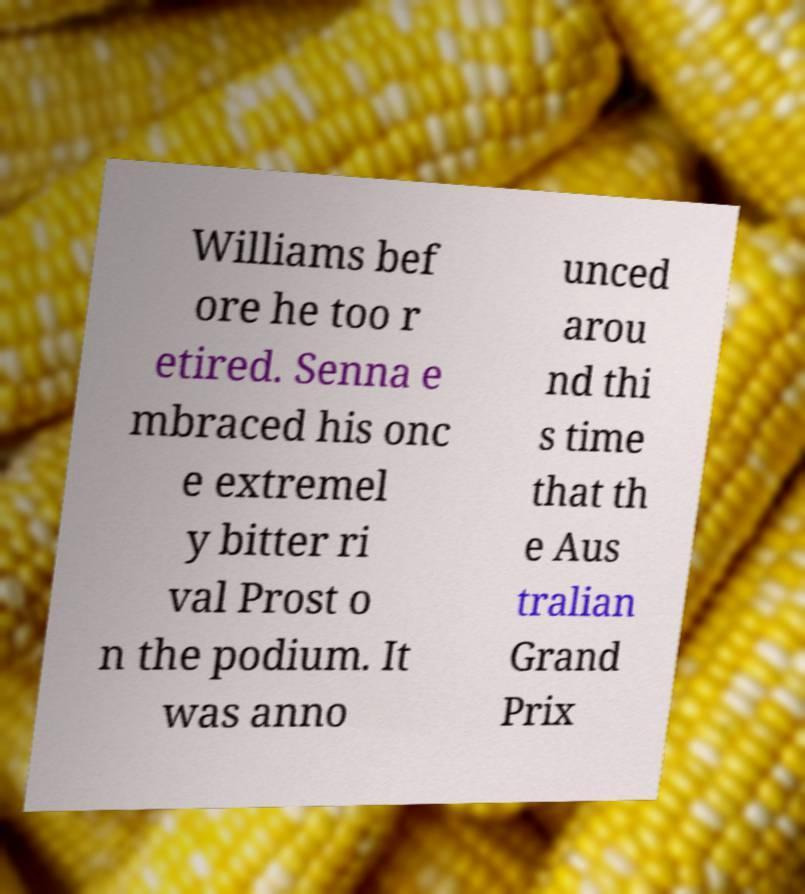I need the written content from this picture converted into text. Can you do that? Williams bef ore he too r etired. Senna e mbraced his onc e extremel y bitter ri val Prost o n the podium. It was anno unced arou nd thi s time that th e Aus tralian Grand Prix 